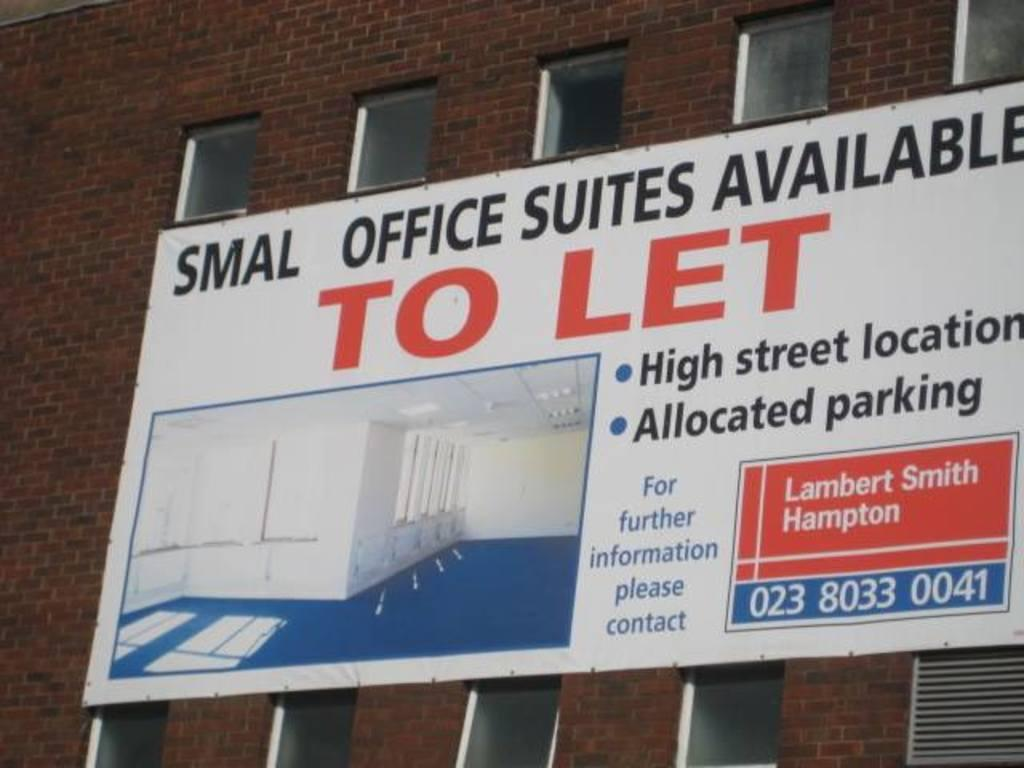What type of structure is visible in the image? There is a building in the image. Is there anything attached to the building? Yes, there is a board attached to the building. What can be found on the board? There is text on the board. What type of bird can be seen flying near the building in the image? There is no bird visible in the image; it only shows a building with a board attached to it. 